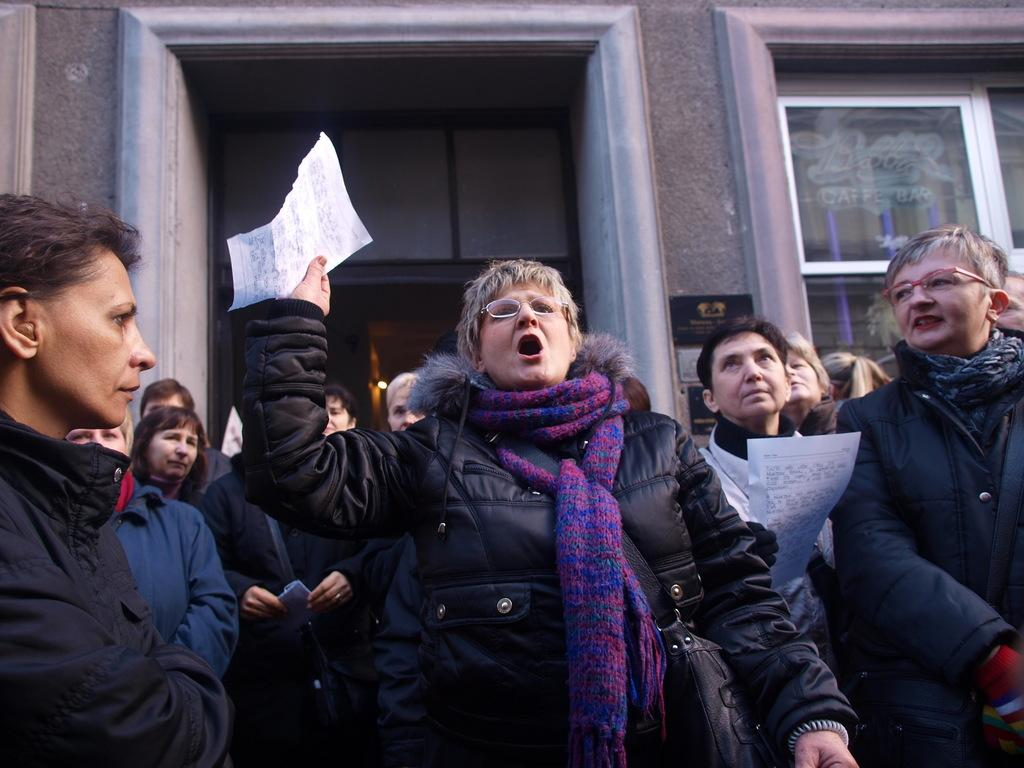How many people are present in the image? There are two people in the image. What are the two people holding in their hands? The two people are holding papers in their hands. Can you describe the background of the image? There are people standing in the background of the image, and there is a building with doors and windows. What type of sign can be seen in the image? There is no sign present in the image. What type of produce is being held by the people in the image? The people in the image are holding papers, not produce. 